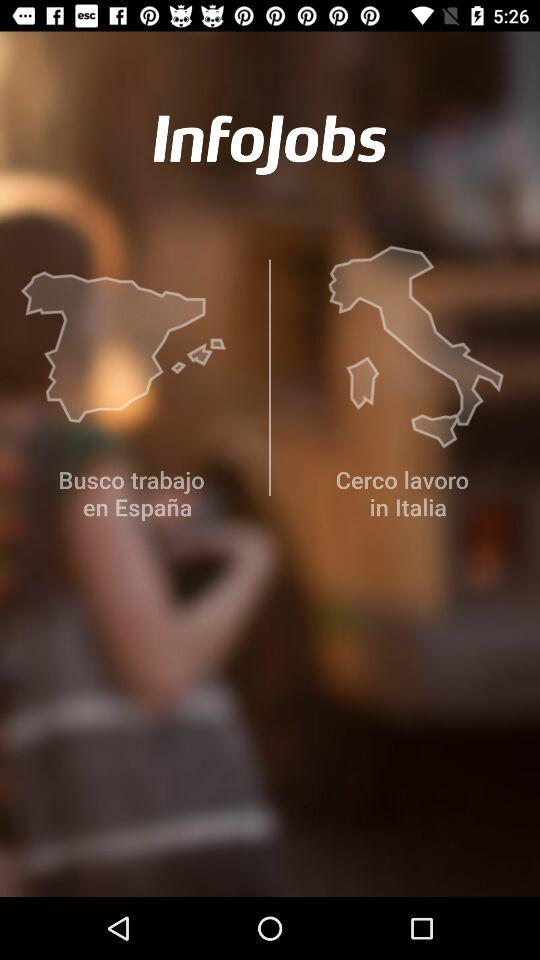What is the application name? The application name is "InfoJobs". 